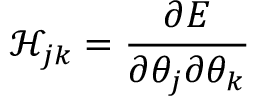Convert formula to latex. <formula><loc_0><loc_0><loc_500><loc_500>\mathcal { H } _ { j k } = \frac { \partial E } { \partial \theta _ { j } \partial \theta _ { k } }</formula> 